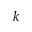Convert formula to latex. <formula><loc_0><loc_0><loc_500><loc_500>k</formula> 